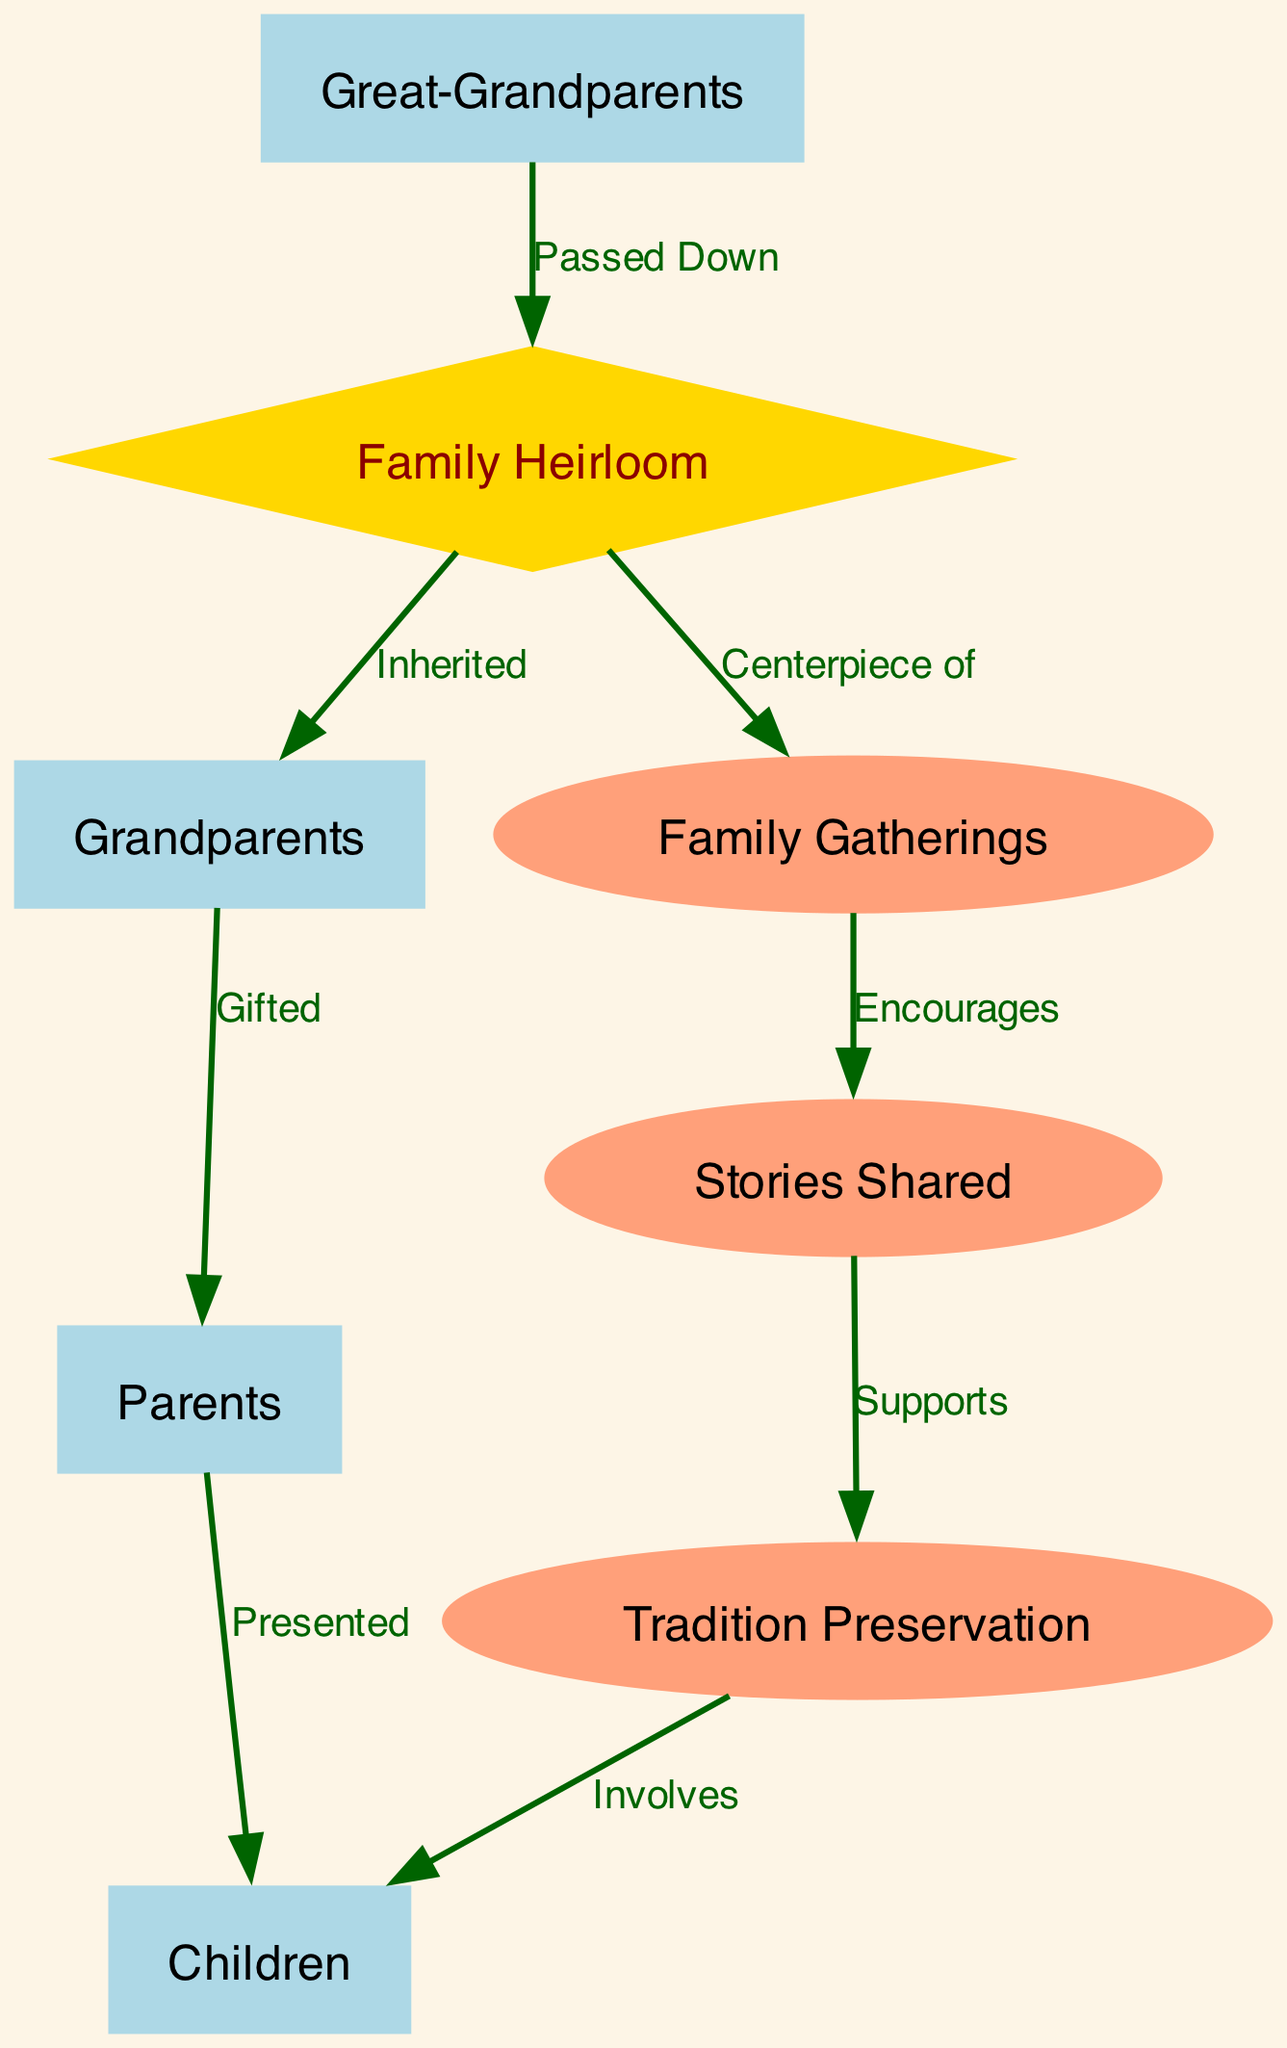What is at the center of family gatherings? The diagram indicates that the Family Heirloom acts as the "Centerpiece of" family gatherings, which means it holds a central role during these events.
Answer: Family Heirloom Who passed down the heirloom? The directed edge from Great-Grandparents to Family Heirloom labeled "Passed Down" indicates that the Great-Grandparents are the ones responsible for this action.
Answer: Great-Grandparents How many nodes are in the diagram? By counting the nodes listed in the data, there are eight distinct nodes represented in the diagram.
Answer: Eight What is inherited from the grandparents? The edge from Family Heirloom to Grandparents labeled "Inherited" indicates that the Family Heirloom is what is inherited from the Great-Grandparents to the Grandparents.
Answer: Family Heirloom Which group is involved in tradition preservation? The diagram shows that the Children are involved in "Tradition Preservation," which is indicated by the edge leading from Tradition Preservation to Children.
Answer: Children When is tradition preservation supported? According to the diagram, the edge from Stories Shared to Tradition Preservation labeled "Supports" indicates that tradition preservation is supported during the sharing of stories.
Answer: Stories Shared What relationship describes how parents receive the heirloom? The edge from Grandparents to Parents labeled "Gifted" outlines that the relationship is one of gifting when it comes to how parents acquire the heirloom.
Answer: Gifted How does the family gathering encourage sharing stories? The directed edge from Family Gatherings to Stories Shared titled "Encourages" indicates that family gatherings play an essential role in promoting the sharing of stories among family members.
Answer: Encourages What does the heirloom involve with the children? There is a directed edge from Tradition Preservation to Children labeled "Involves," which conveys that preserving tradition includes the participation of the Children.
Answer: Children 